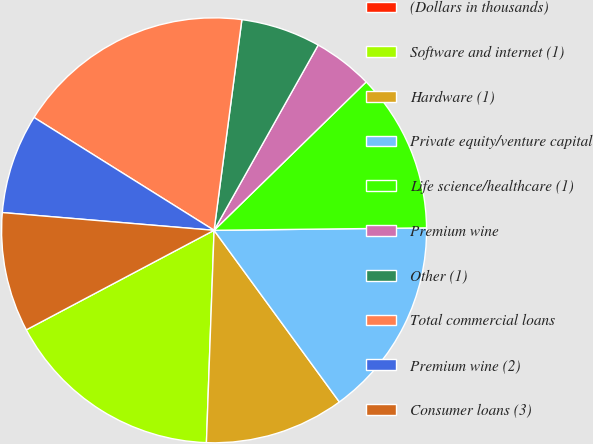<chart> <loc_0><loc_0><loc_500><loc_500><pie_chart><fcel>(Dollars in thousands)<fcel>Software and internet (1)<fcel>Hardware (1)<fcel>Private equity/venture capital<fcel>Life science/healthcare (1)<fcel>Premium wine<fcel>Other (1)<fcel>Total commercial loans<fcel>Premium wine (2)<fcel>Consumer loans (3)<nl><fcel>0.0%<fcel>16.67%<fcel>10.61%<fcel>15.15%<fcel>12.12%<fcel>4.55%<fcel>6.06%<fcel>18.18%<fcel>7.58%<fcel>9.09%<nl></chart> 